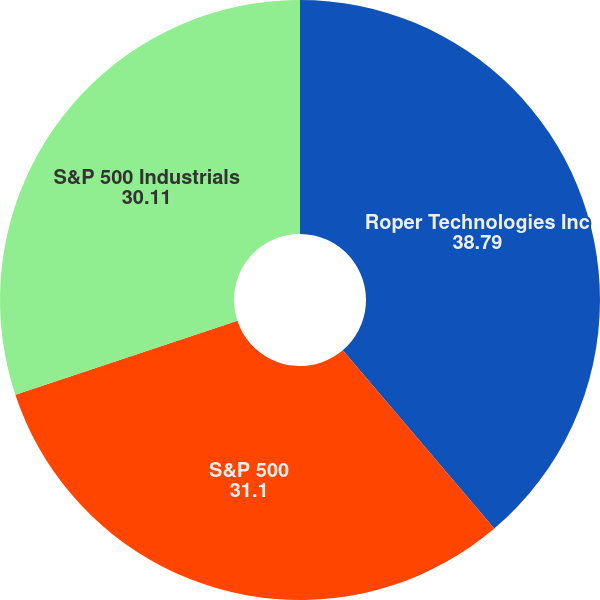Convert chart to OTSL. <chart><loc_0><loc_0><loc_500><loc_500><pie_chart><fcel>Roper Technologies Inc<fcel>S&P 500<fcel>S&P 500 Industrials<nl><fcel>38.79%<fcel>31.1%<fcel>30.11%<nl></chart> 